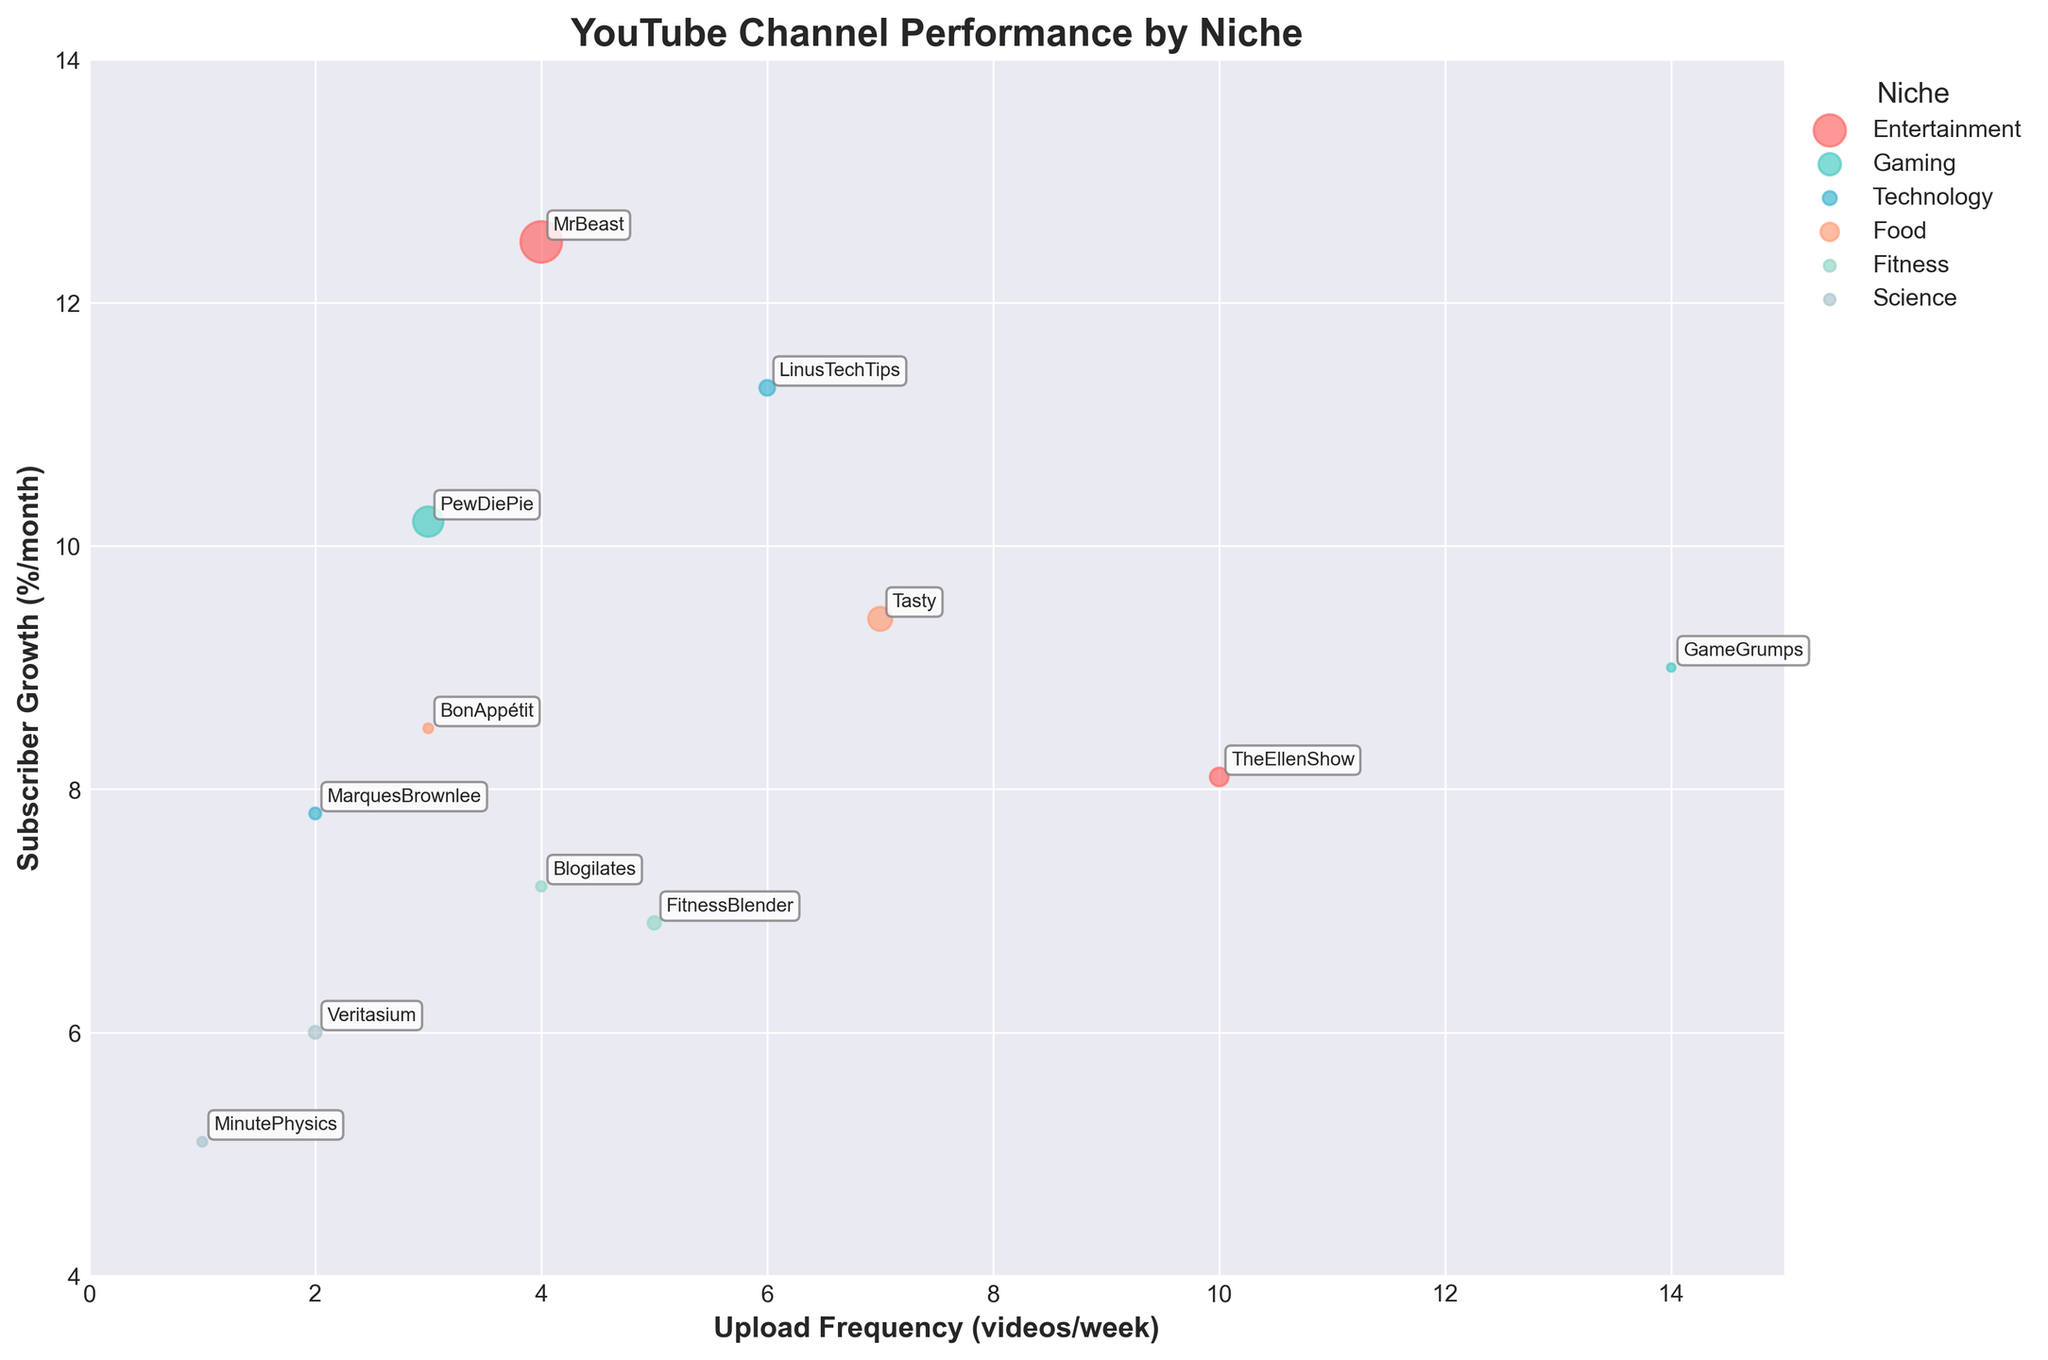What's the upload frequency and subscriber growth for MrBeast? From the figure, locate MrBeast's bubble, and note its position on the x-axis and y-axis. MrBeast is shown with 4 videos per week on the x-axis and a 12.5% monthly subscriber growth on the y-axis.
Answer: 4 videos/week and 12.5%/month Which YouTube niche has the highest average view per video? Look at the size of the bubbles, as the size indicates average views per video. The largest bubble is for MrBeast in the Entertainment niche.
Answer: Entertainment Which channel in the Technology niche has a higher subscriber growth, MarquesBrownlee or LinusTechTips? Compare the y-axis values for the two channels in the Technology niche. MarquesBrownlee has a subscriber growth of 7.8%, while LinusTechTips has 11.3%.
Answer: LinusTechTips How does the upload frequency of Tasty compare to that of TheEllenShow? Check the x-axis positions for the bubbles corresponding to Tasty and TheEllenShow. Tasty uploads 7 videos per week, and TheEllenShow uploads 10.
Answer: TheEllenShow has a higher frequency What is the overall trend between upload frequency and subscriber growth? Observe the general direction of the bubbles in the plot. As upload frequency increases, there seems to be an overall increase in subscriber growth, indicating a positive correlation.
Answer: Positive correlation Which channel has the smallest bubble in the plot, and what does it represent? Identify the smallest bubble, which is for GameGrumps. This represents the lowest average view per video among the shown data.
Answer: GameGrumps Which Science channel has a higher average view per video, Veritasium or MinutePhysics? Compare the bubble sizes of Veritasium and MinutePhysics; Veritasium’s bubble is larger.
Answer: Veritasium If a channel from the Food niche uploads 3 videos per week, what can be inferred about its subscriber growth from the plot? Look at bubbles in the Food niche around 3 videos per week for Tasty and BonAppétit. Subscriber growth for these channels is around 9.4% and 8.5%.
Answer: Around 8.5-9.4% What is the subscriber growth difference between PewDiePie and GameGrumps? Locate both channels’ bubbles and note their y-axis values for subscriber growth - PewDiePie with 10.2%, and GameGrumps with 9.0%. The difference is 10.2% - 9.0%.
Answer: 1.2% How do the upload frequencies of FitnessBlender and Blogilates compare, and what’s their subscriber growth difference? FitnessBlender uploads 5 videos per week and Blogilates uploads 4. Check their y-axis values; 6.9% for FitnessBlender and 7.2% for Blogilates. 7.2% - 6.9% equals 0.3%.
Answer: FitnessBlender uploads more, 0.3% in growth 